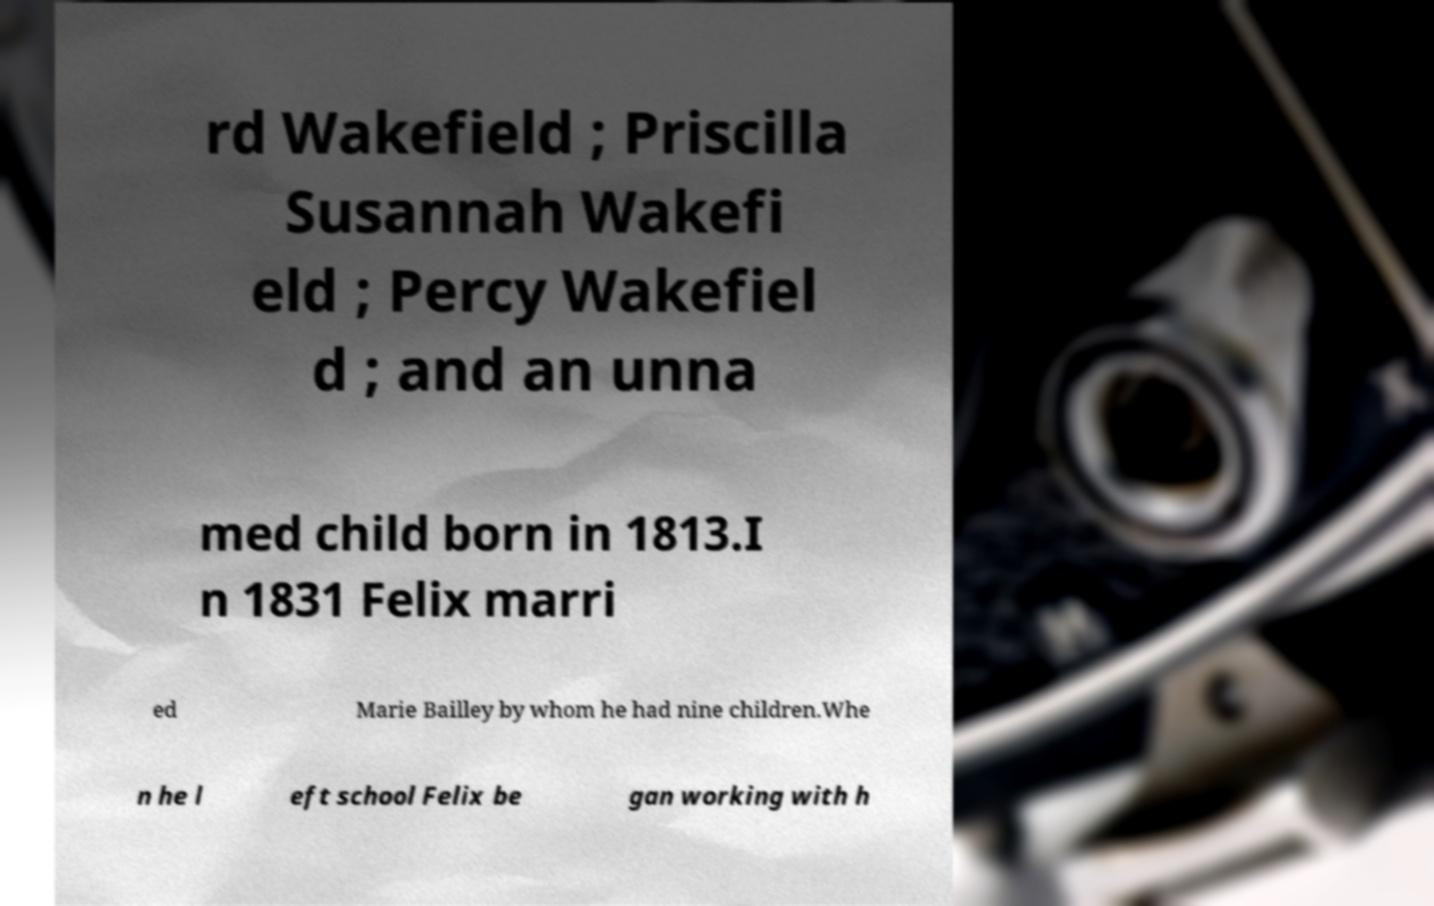What messages or text are displayed in this image? I need them in a readable, typed format. rd Wakefield ; Priscilla Susannah Wakefi eld ; Percy Wakefiel d ; and an unna med child born in 1813.I n 1831 Felix marri ed Marie Bailley by whom he had nine children.Whe n he l eft school Felix be gan working with h 